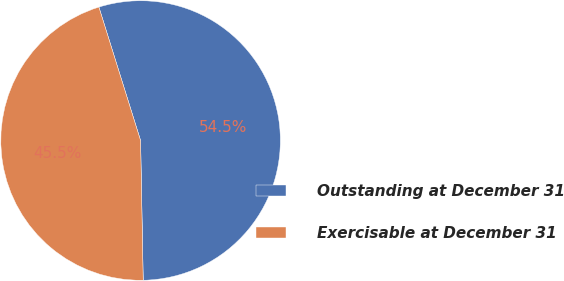<chart> <loc_0><loc_0><loc_500><loc_500><pie_chart><fcel>Outstanding at December 31<fcel>Exercisable at December 31<nl><fcel>54.52%<fcel>45.48%<nl></chart> 